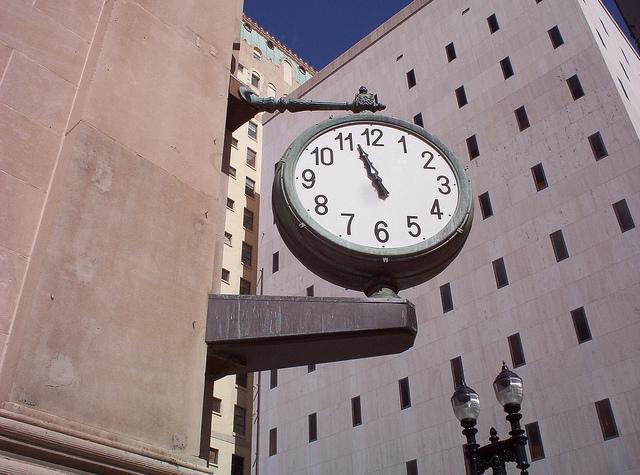How many people holds a cup?
Give a very brief answer. 0. 